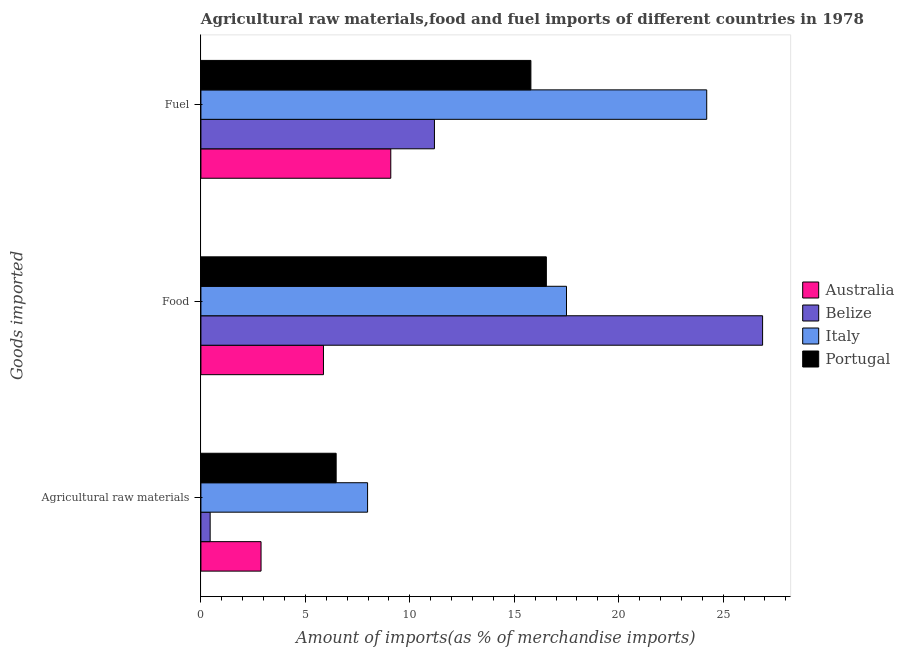How many different coloured bars are there?
Your answer should be compact. 4. How many bars are there on the 3rd tick from the top?
Ensure brevity in your answer.  4. What is the label of the 3rd group of bars from the top?
Keep it short and to the point. Agricultural raw materials. What is the percentage of raw materials imports in Australia?
Ensure brevity in your answer.  2.88. Across all countries, what is the maximum percentage of fuel imports?
Your answer should be very brief. 24.22. Across all countries, what is the minimum percentage of food imports?
Offer a very short reply. 5.87. In which country was the percentage of food imports maximum?
Ensure brevity in your answer.  Belize. What is the total percentage of raw materials imports in the graph?
Your answer should be very brief. 17.78. What is the difference between the percentage of raw materials imports in Portugal and that in Italy?
Provide a short and direct response. -1.5. What is the difference between the percentage of fuel imports in Australia and the percentage of raw materials imports in Italy?
Your answer should be very brief. 1.11. What is the average percentage of food imports per country?
Your answer should be compact. 16.7. What is the difference between the percentage of fuel imports and percentage of raw materials imports in Italy?
Provide a short and direct response. 16.24. In how many countries, is the percentage of raw materials imports greater than 9 %?
Ensure brevity in your answer.  0. What is the ratio of the percentage of raw materials imports in Australia to that in Belize?
Keep it short and to the point. 6.5. What is the difference between the highest and the second highest percentage of food imports?
Ensure brevity in your answer.  9.39. What is the difference between the highest and the lowest percentage of food imports?
Make the answer very short. 21.02. In how many countries, is the percentage of raw materials imports greater than the average percentage of raw materials imports taken over all countries?
Give a very brief answer. 2. How many bars are there?
Make the answer very short. 12. Are all the bars in the graph horizontal?
Make the answer very short. Yes. Where does the legend appear in the graph?
Your answer should be compact. Center right. How many legend labels are there?
Your answer should be very brief. 4. How are the legend labels stacked?
Your answer should be compact. Vertical. What is the title of the graph?
Your response must be concise. Agricultural raw materials,food and fuel imports of different countries in 1978. What is the label or title of the X-axis?
Your answer should be compact. Amount of imports(as % of merchandise imports). What is the label or title of the Y-axis?
Make the answer very short. Goods imported. What is the Amount of imports(as % of merchandise imports) in Australia in Agricultural raw materials?
Ensure brevity in your answer.  2.88. What is the Amount of imports(as % of merchandise imports) of Belize in Agricultural raw materials?
Provide a succinct answer. 0.44. What is the Amount of imports(as % of merchandise imports) of Italy in Agricultural raw materials?
Your response must be concise. 7.98. What is the Amount of imports(as % of merchandise imports) of Portugal in Agricultural raw materials?
Make the answer very short. 6.47. What is the Amount of imports(as % of merchandise imports) in Australia in Food?
Your answer should be compact. 5.87. What is the Amount of imports(as % of merchandise imports) in Belize in Food?
Make the answer very short. 26.89. What is the Amount of imports(as % of merchandise imports) in Italy in Food?
Your answer should be compact. 17.5. What is the Amount of imports(as % of merchandise imports) of Portugal in Food?
Give a very brief answer. 16.54. What is the Amount of imports(as % of merchandise imports) of Australia in Fuel?
Offer a terse response. 9.09. What is the Amount of imports(as % of merchandise imports) in Belize in Fuel?
Give a very brief answer. 11.18. What is the Amount of imports(as % of merchandise imports) of Italy in Fuel?
Ensure brevity in your answer.  24.22. What is the Amount of imports(as % of merchandise imports) of Portugal in Fuel?
Provide a succinct answer. 15.8. Across all Goods imported, what is the maximum Amount of imports(as % of merchandise imports) of Australia?
Give a very brief answer. 9.09. Across all Goods imported, what is the maximum Amount of imports(as % of merchandise imports) of Belize?
Ensure brevity in your answer.  26.89. Across all Goods imported, what is the maximum Amount of imports(as % of merchandise imports) of Italy?
Make the answer very short. 24.22. Across all Goods imported, what is the maximum Amount of imports(as % of merchandise imports) in Portugal?
Give a very brief answer. 16.54. Across all Goods imported, what is the minimum Amount of imports(as % of merchandise imports) in Australia?
Offer a very short reply. 2.88. Across all Goods imported, what is the minimum Amount of imports(as % of merchandise imports) of Belize?
Provide a short and direct response. 0.44. Across all Goods imported, what is the minimum Amount of imports(as % of merchandise imports) of Italy?
Offer a very short reply. 7.98. Across all Goods imported, what is the minimum Amount of imports(as % of merchandise imports) of Portugal?
Offer a very short reply. 6.47. What is the total Amount of imports(as % of merchandise imports) in Australia in the graph?
Ensure brevity in your answer.  17.84. What is the total Amount of imports(as % of merchandise imports) in Belize in the graph?
Make the answer very short. 38.51. What is the total Amount of imports(as % of merchandise imports) in Italy in the graph?
Give a very brief answer. 49.7. What is the total Amount of imports(as % of merchandise imports) of Portugal in the graph?
Your answer should be very brief. 38.81. What is the difference between the Amount of imports(as % of merchandise imports) of Australia in Agricultural raw materials and that in Food?
Provide a short and direct response. -2.99. What is the difference between the Amount of imports(as % of merchandise imports) of Belize in Agricultural raw materials and that in Food?
Your response must be concise. -26.45. What is the difference between the Amount of imports(as % of merchandise imports) of Italy in Agricultural raw materials and that in Food?
Your answer should be compact. -9.52. What is the difference between the Amount of imports(as % of merchandise imports) in Portugal in Agricultural raw materials and that in Food?
Your answer should be compact. -10.06. What is the difference between the Amount of imports(as % of merchandise imports) in Australia in Agricultural raw materials and that in Fuel?
Ensure brevity in your answer.  -6.21. What is the difference between the Amount of imports(as % of merchandise imports) in Belize in Agricultural raw materials and that in Fuel?
Keep it short and to the point. -10.74. What is the difference between the Amount of imports(as % of merchandise imports) in Italy in Agricultural raw materials and that in Fuel?
Your answer should be very brief. -16.24. What is the difference between the Amount of imports(as % of merchandise imports) of Portugal in Agricultural raw materials and that in Fuel?
Your answer should be compact. -9.32. What is the difference between the Amount of imports(as % of merchandise imports) of Australia in Food and that in Fuel?
Provide a succinct answer. -3.22. What is the difference between the Amount of imports(as % of merchandise imports) of Belize in Food and that in Fuel?
Keep it short and to the point. 15.71. What is the difference between the Amount of imports(as % of merchandise imports) in Italy in Food and that in Fuel?
Offer a terse response. -6.71. What is the difference between the Amount of imports(as % of merchandise imports) in Portugal in Food and that in Fuel?
Ensure brevity in your answer.  0.74. What is the difference between the Amount of imports(as % of merchandise imports) in Australia in Agricultural raw materials and the Amount of imports(as % of merchandise imports) in Belize in Food?
Offer a very short reply. -24.01. What is the difference between the Amount of imports(as % of merchandise imports) in Australia in Agricultural raw materials and the Amount of imports(as % of merchandise imports) in Italy in Food?
Your response must be concise. -14.62. What is the difference between the Amount of imports(as % of merchandise imports) of Australia in Agricultural raw materials and the Amount of imports(as % of merchandise imports) of Portugal in Food?
Offer a very short reply. -13.66. What is the difference between the Amount of imports(as % of merchandise imports) of Belize in Agricultural raw materials and the Amount of imports(as % of merchandise imports) of Italy in Food?
Your answer should be very brief. -17.06. What is the difference between the Amount of imports(as % of merchandise imports) of Belize in Agricultural raw materials and the Amount of imports(as % of merchandise imports) of Portugal in Food?
Your answer should be compact. -16.1. What is the difference between the Amount of imports(as % of merchandise imports) in Italy in Agricultural raw materials and the Amount of imports(as % of merchandise imports) in Portugal in Food?
Your response must be concise. -8.56. What is the difference between the Amount of imports(as % of merchandise imports) of Australia in Agricultural raw materials and the Amount of imports(as % of merchandise imports) of Belize in Fuel?
Provide a succinct answer. -8.3. What is the difference between the Amount of imports(as % of merchandise imports) of Australia in Agricultural raw materials and the Amount of imports(as % of merchandise imports) of Italy in Fuel?
Your answer should be very brief. -21.34. What is the difference between the Amount of imports(as % of merchandise imports) of Australia in Agricultural raw materials and the Amount of imports(as % of merchandise imports) of Portugal in Fuel?
Provide a succinct answer. -12.92. What is the difference between the Amount of imports(as % of merchandise imports) in Belize in Agricultural raw materials and the Amount of imports(as % of merchandise imports) in Italy in Fuel?
Your response must be concise. -23.77. What is the difference between the Amount of imports(as % of merchandise imports) in Belize in Agricultural raw materials and the Amount of imports(as % of merchandise imports) in Portugal in Fuel?
Your answer should be very brief. -15.35. What is the difference between the Amount of imports(as % of merchandise imports) of Italy in Agricultural raw materials and the Amount of imports(as % of merchandise imports) of Portugal in Fuel?
Keep it short and to the point. -7.82. What is the difference between the Amount of imports(as % of merchandise imports) of Australia in Food and the Amount of imports(as % of merchandise imports) of Belize in Fuel?
Keep it short and to the point. -5.31. What is the difference between the Amount of imports(as % of merchandise imports) of Australia in Food and the Amount of imports(as % of merchandise imports) of Italy in Fuel?
Your answer should be very brief. -18.35. What is the difference between the Amount of imports(as % of merchandise imports) in Australia in Food and the Amount of imports(as % of merchandise imports) in Portugal in Fuel?
Your answer should be compact. -9.93. What is the difference between the Amount of imports(as % of merchandise imports) of Belize in Food and the Amount of imports(as % of merchandise imports) of Italy in Fuel?
Give a very brief answer. 2.68. What is the difference between the Amount of imports(as % of merchandise imports) of Belize in Food and the Amount of imports(as % of merchandise imports) of Portugal in Fuel?
Give a very brief answer. 11.09. What is the difference between the Amount of imports(as % of merchandise imports) of Italy in Food and the Amount of imports(as % of merchandise imports) of Portugal in Fuel?
Offer a terse response. 1.71. What is the average Amount of imports(as % of merchandise imports) of Australia per Goods imported?
Keep it short and to the point. 5.95. What is the average Amount of imports(as % of merchandise imports) in Belize per Goods imported?
Ensure brevity in your answer.  12.84. What is the average Amount of imports(as % of merchandise imports) of Italy per Goods imported?
Give a very brief answer. 16.57. What is the average Amount of imports(as % of merchandise imports) in Portugal per Goods imported?
Offer a very short reply. 12.94. What is the difference between the Amount of imports(as % of merchandise imports) of Australia and Amount of imports(as % of merchandise imports) of Belize in Agricultural raw materials?
Provide a short and direct response. 2.44. What is the difference between the Amount of imports(as % of merchandise imports) of Australia and Amount of imports(as % of merchandise imports) of Italy in Agricultural raw materials?
Your response must be concise. -5.1. What is the difference between the Amount of imports(as % of merchandise imports) of Australia and Amount of imports(as % of merchandise imports) of Portugal in Agricultural raw materials?
Provide a succinct answer. -3.6. What is the difference between the Amount of imports(as % of merchandise imports) of Belize and Amount of imports(as % of merchandise imports) of Italy in Agricultural raw materials?
Provide a short and direct response. -7.54. What is the difference between the Amount of imports(as % of merchandise imports) of Belize and Amount of imports(as % of merchandise imports) of Portugal in Agricultural raw materials?
Offer a terse response. -6.03. What is the difference between the Amount of imports(as % of merchandise imports) in Italy and Amount of imports(as % of merchandise imports) in Portugal in Agricultural raw materials?
Make the answer very short. 1.5. What is the difference between the Amount of imports(as % of merchandise imports) in Australia and Amount of imports(as % of merchandise imports) in Belize in Food?
Keep it short and to the point. -21.02. What is the difference between the Amount of imports(as % of merchandise imports) in Australia and Amount of imports(as % of merchandise imports) in Italy in Food?
Keep it short and to the point. -11.64. What is the difference between the Amount of imports(as % of merchandise imports) of Australia and Amount of imports(as % of merchandise imports) of Portugal in Food?
Your answer should be compact. -10.67. What is the difference between the Amount of imports(as % of merchandise imports) in Belize and Amount of imports(as % of merchandise imports) in Italy in Food?
Make the answer very short. 9.39. What is the difference between the Amount of imports(as % of merchandise imports) in Belize and Amount of imports(as % of merchandise imports) in Portugal in Food?
Offer a terse response. 10.35. What is the difference between the Amount of imports(as % of merchandise imports) in Italy and Amount of imports(as % of merchandise imports) in Portugal in Food?
Offer a terse response. 0.96. What is the difference between the Amount of imports(as % of merchandise imports) of Australia and Amount of imports(as % of merchandise imports) of Belize in Fuel?
Your answer should be very brief. -2.09. What is the difference between the Amount of imports(as % of merchandise imports) in Australia and Amount of imports(as % of merchandise imports) in Italy in Fuel?
Give a very brief answer. -15.13. What is the difference between the Amount of imports(as % of merchandise imports) of Australia and Amount of imports(as % of merchandise imports) of Portugal in Fuel?
Ensure brevity in your answer.  -6.71. What is the difference between the Amount of imports(as % of merchandise imports) of Belize and Amount of imports(as % of merchandise imports) of Italy in Fuel?
Your answer should be very brief. -13.04. What is the difference between the Amount of imports(as % of merchandise imports) of Belize and Amount of imports(as % of merchandise imports) of Portugal in Fuel?
Your response must be concise. -4.62. What is the difference between the Amount of imports(as % of merchandise imports) in Italy and Amount of imports(as % of merchandise imports) in Portugal in Fuel?
Make the answer very short. 8.42. What is the ratio of the Amount of imports(as % of merchandise imports) of Australia in Agricultural raw materials to that in Food?
Your answer should be very brief. 0.49. What is the ratio of the Amount of imports(as % of merchandise imports) of Belize in Agricultural raw materials to that in Food?
Your response must be concise. 0.02. What is the ratio of the Amount of imports(as % of merchandise imports) of Italy in Agricultural raw materials to that in Food?
Make the answer very short. 0.46. What is the ratio of the Amount of imports(as % of merchandise imports) of Portugal in Agricultural raw materials to that in Food?
Give a very brief answer. 0.39. What is the ratio of the Amount of imports(as % of merchandise imports) in Australia in Agricultural raw materials to that in Fuel?
Ensure brevity in your answer.  0.32. What is the ratio of the Amount of imports(as % of merchandise imports) in Belize in Agricultural raw materials to that in Fuel?
Give a very brief answer. 0.04. What is the ratio of the Amount of imports(as % of merchandise imports) in Italy in Agricultural raw materials to that in Fuel?
Your answer should be very brief. 0.33. What is the ratio of the Amount of imports(as % of merchandise imports) of Portugal in Agricultural raw materials to that in Fuel?
Your answer should be compact. 0.41. What is the ratio of the Amount of imports(as % of merchandise imports) of Australia in Food to that in Fuel?
Provide a short and direct response. 0.65. What is the ratio of the Amount of imports(as % of merchandise imports) in Belize in Food to that in Fuel?
Provide a succinct answer. 2.41. What is the ratio of the Amount of imports(as % of merchandise imports) in Italy in Food to that in Fuel?
Offer a terse response. 0.72. What is the ratio of the Amount of imports(as % of merchandise imports) of Portugal in Food to that in Fuel?
Your answer should be very brief. 1.05. What is the difference between the highest and the second highest Amount of imports(as % of merchandise imports) in Australia?
Your answer should be very brief. 3.22. What is the difference between the highest and the second highest Amount of imports(as % of merchandise imports) of Belize?
Offer a very short reply. 15.71. What is the difference between the highest and the second highest Amount of imports(as % of merchandise imports) in Italy?
Keep it short and to the point. 6.71. What is the difference between the highest and the second highest Amount of imports(as % of merchandise imports) in Portugal?
Your answer should be compact. 0.74. What is the difference between the highest and the lowest Amount of imports(as % of merchandise imports) of Australia?
Ensure brevity in your answer.  6.21. What is the difference between the highest and the lowest Amount of imports(as % of merchandise imports) of Belize?
Keep it short and to the point. 26.45. What is the difference between the highest and the lowest Amount of imports(as % of merchandise imports) in Italy?
Provide a short and direct response. 16.24. What is the difference between the highest and the lowest Amount of imports(as % of merchandise imports) in Portugal?
Provide a succinct answer. 10.06. 